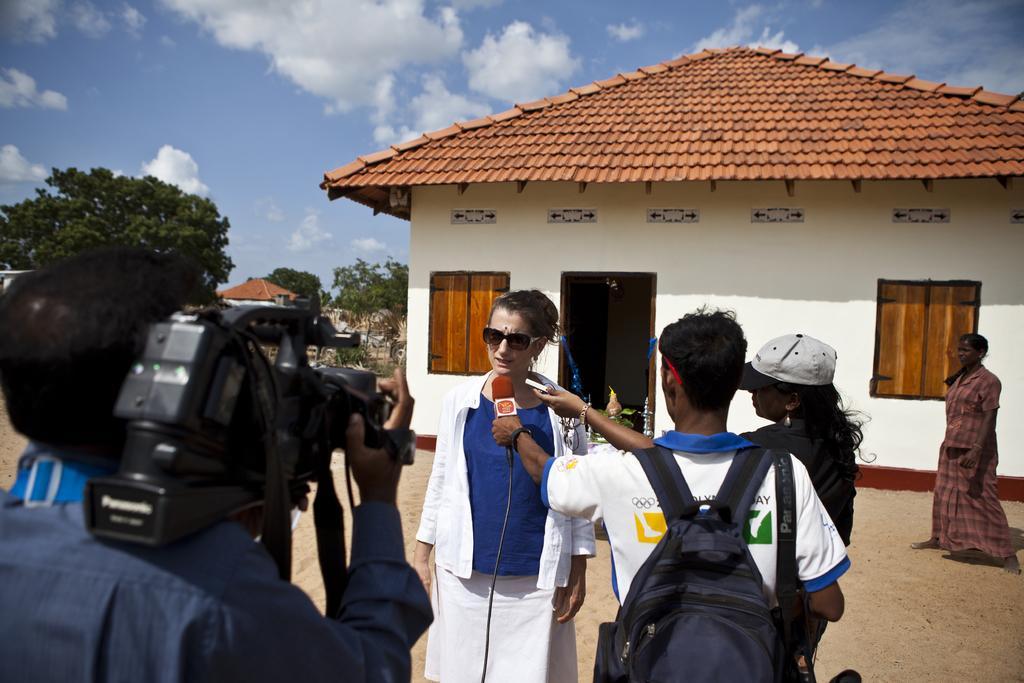In one or two sentences, can you explain what this image depicts? This is the picture taken in the outdoor, there are group of people standing on the floor. The man in blue shirt holding a camera and the other man man in white t shirt wearing a bag and holding microphone. Background of this people is a house, tree and a sky with clouds. 